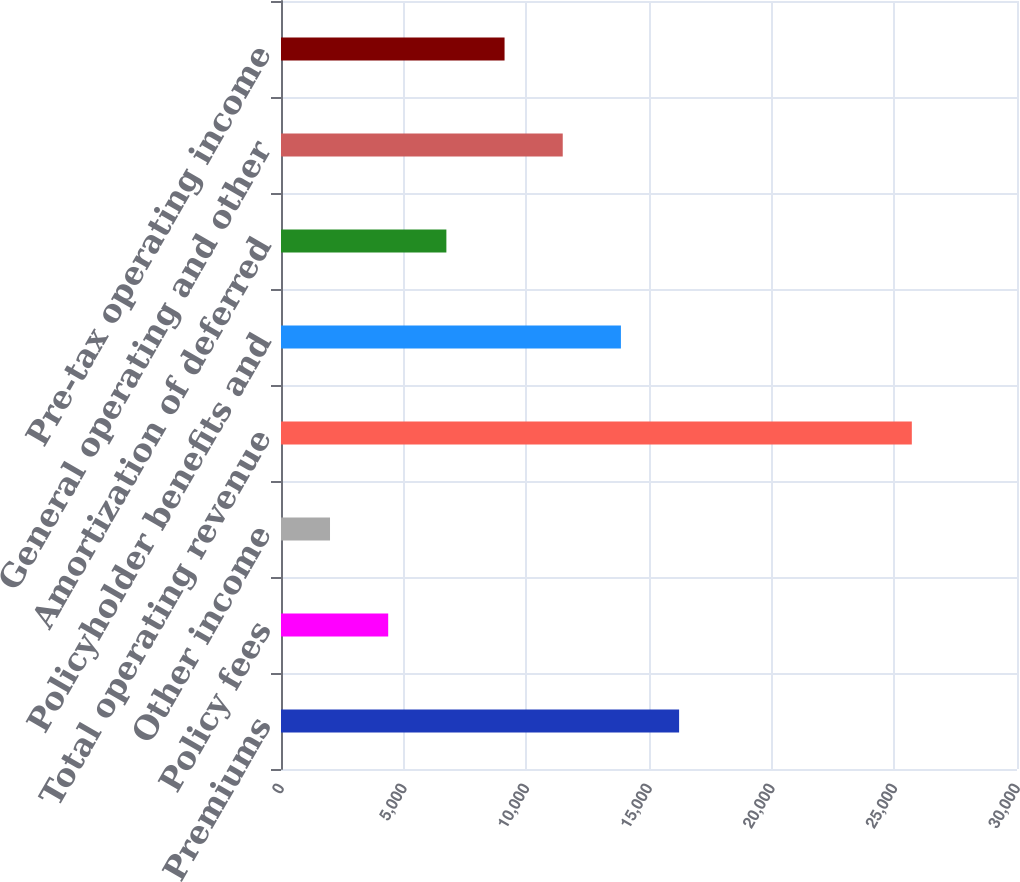<chart> <loc_0><loc_0><loc_500><loc_500><bar_chart><fcel>Premiums<fcel>Policy fees<fcel>Other income<fcel>Total operating revenue<fcel>Policyholder benefits and<fcel>Amortization of deferred<fcel>General operating and other<fcel>Pre-tax operating income<nl><fcel>16227<fcel>4369.5<fcel>1998<fcel>25713<fcel>13855.5<fcel>6741<fcel>11484<fcel>9112.5<nl></chart> 